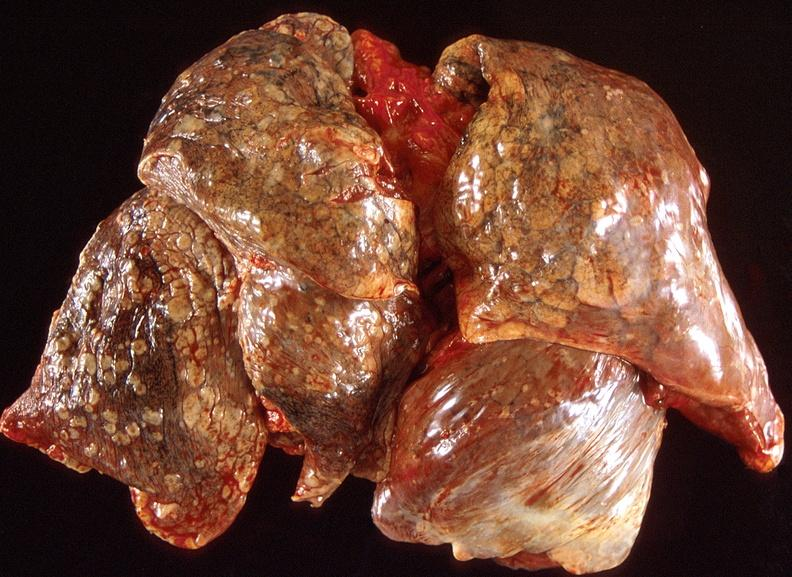where is this?
Answer the question using a single word or phrase. Lung 